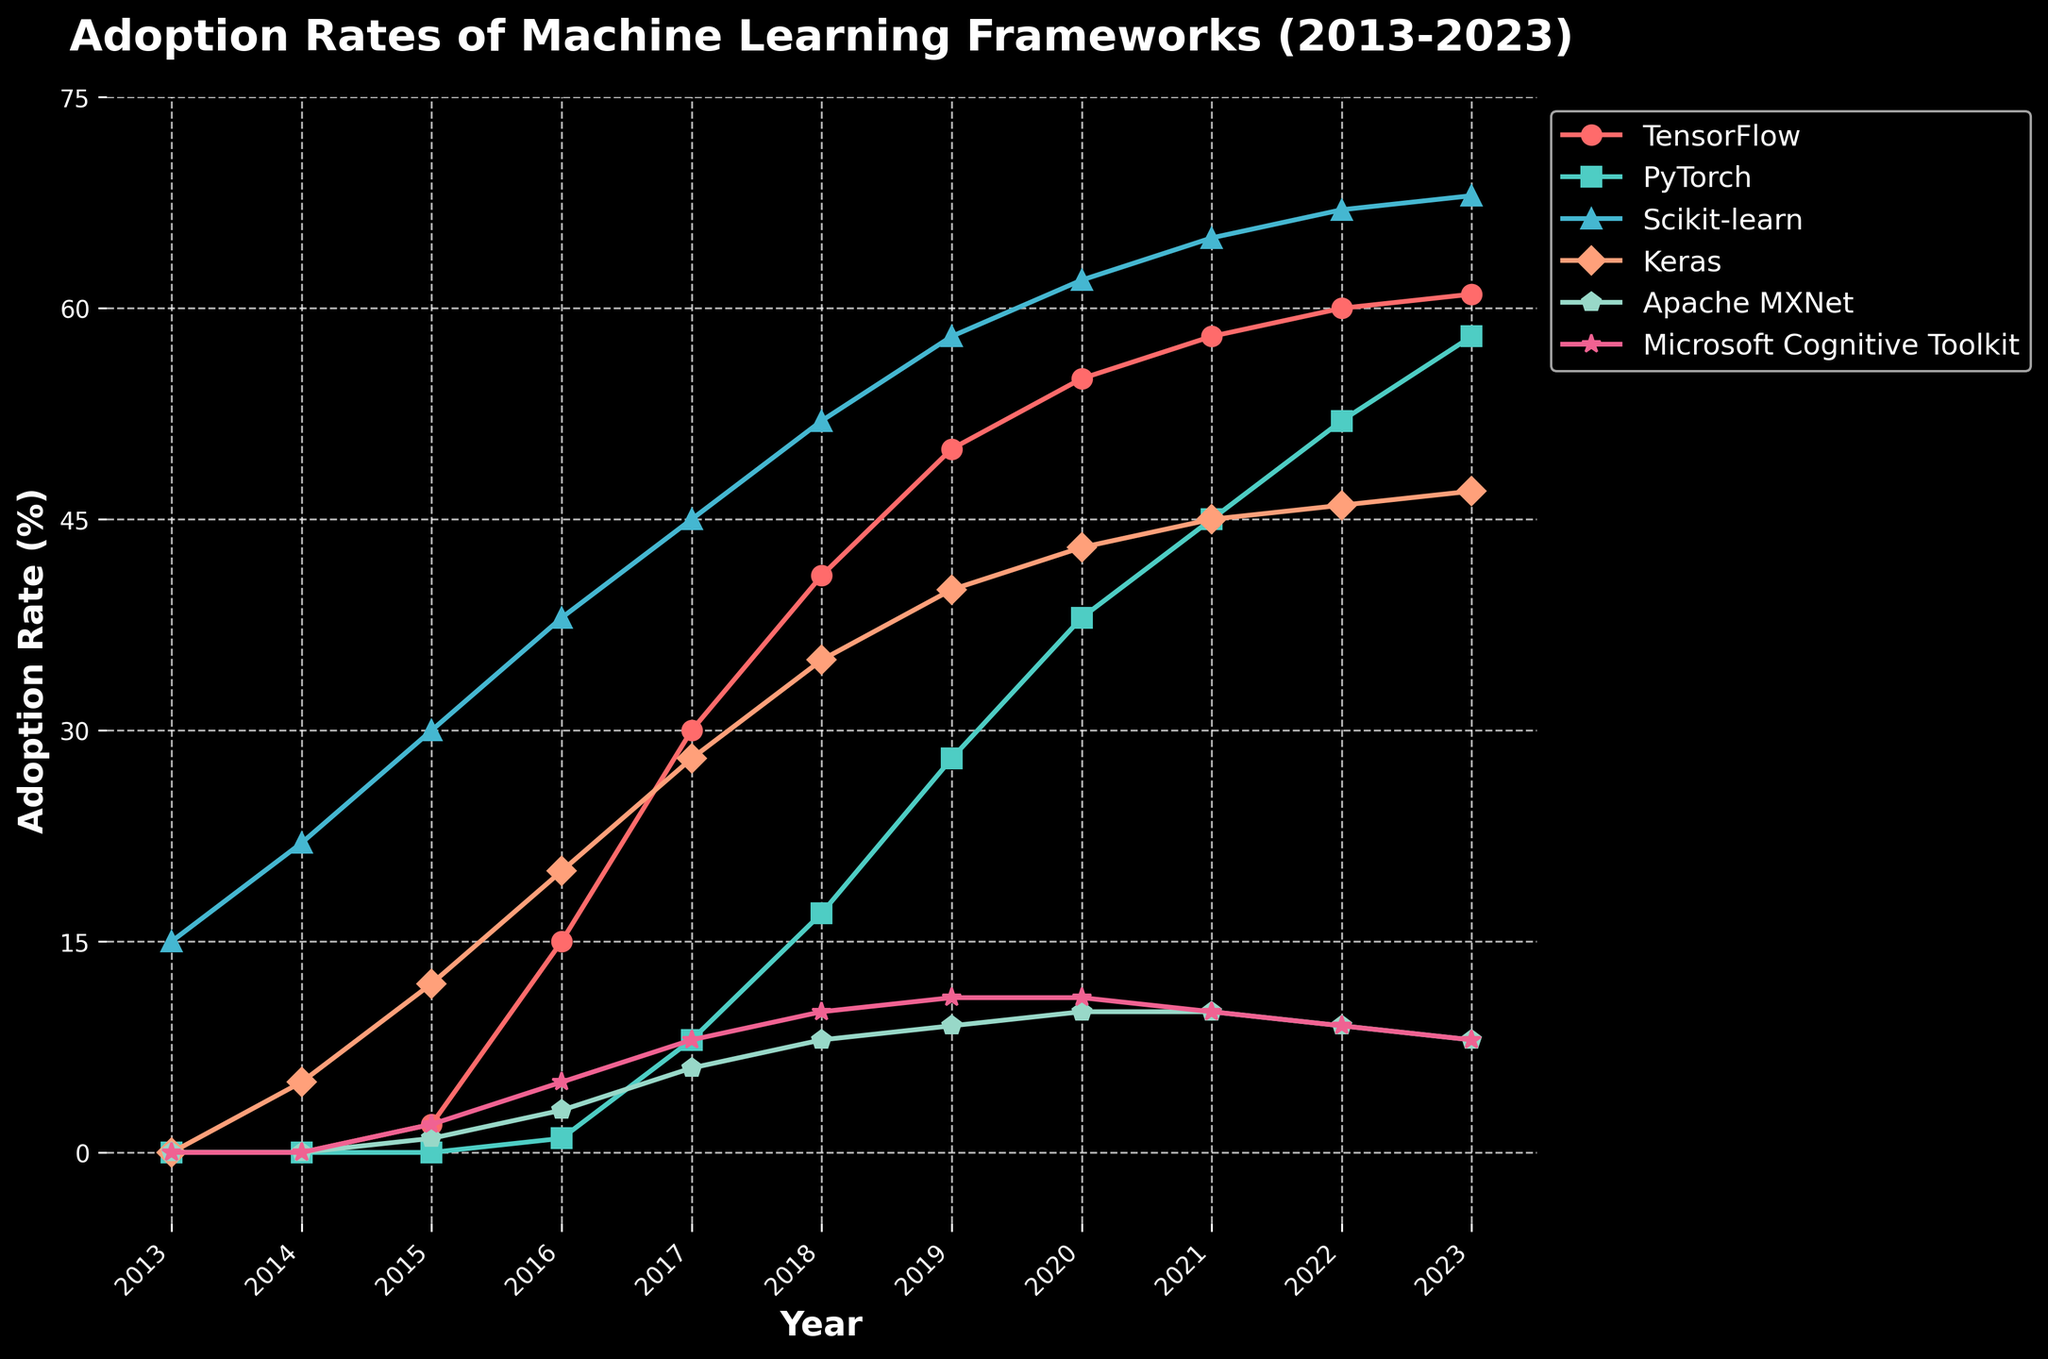What was the adoption rate of TensorFlow in 2016 and 2019? From the figure, locate the point for TensorFlow at 2016 and 2019. In 2016, the adoption rate is 15%; in 2019, it is 50%.
Answer: 15% in 2016, 50% in 2019 Which framework showed the highest adoption rate in 2023? Check the heights of the lines in the figure at the 2023 mark. Scikit-learn is the highest with an adoption rate of 68%.
Answer: Scikit-learn Between 2015 and 2020, which framework had the most significant increase in adoption rate? Calculate the differences in adoption rates for each framework between 2015 and 2020. TensorFlow increases from 2% to 55%, which is the largest difference of 53%.
Answer: TensorFlow How does the adoption rate of PyTorch in 2021 compare to that of Keras in the same year? Compare the heights of the lines for PyTorch and Keras at the 2021 mark. PyTorch has a rate of 45%, while Keras has a rate of 45%. They are equal.
Answer: Equal Which framework had the smallest change in adoption from 2017 to 2023? Calculate the difference in adoption rates between 2017 and 2023 for all frameworks. Microsoft Cognitive Toolkit changes from 8% to 8%, which is a change of 0%.
Answer: Microsoft Cognitive Toolkit What year did Apache MXNet reach its peak adoption rate? Look at the line for Apache MXNet and locate the year with the highest point. The peak adoption rate for Apache MXNet occurred in 2020.
Answer: 2020 What is the average adoption rate of TensorFlow from 2013 to 2023? Sum the adoption rates of TensorFlow for each year from 2013 to 2023 (0+0+2+15+30+41+50+55+58+60+61) which equals 372. Divide by the number of years (11) to get the average. 372/11 = 33.82%.
Answer: 33.82% Compare the growth trends of TensorFlow and PyTorch from 2018 to 2023. Analyze the slopes of the lines for TensorFlow and PyTorch from 2018 to 2023. TensorFlow increases from 41% to 61%, less steep. PyTorch increases from 17% to 58%, steeper increase.
Answer: PyTorch grew faster Which framework had a greater increase in adoption rate between 2019 and 2023, Keras or PyTorch? Calculate the difference in adoption rates between 2019 and 2023 for Keras (47 - 40 = 7%) and PyTorch (58 - 28 = 30%). PyTorch had a greater increase.
Answer: PyTorch What was the adoption rate of Scikit-learn in 2017 and 2023? Identify the points for Scikit-learn at 2017 and 2023. In 2017, the adoption rate is 45%, and in 2023, it is 68%.
Answer: 45% in 2017, 68% in 2023 